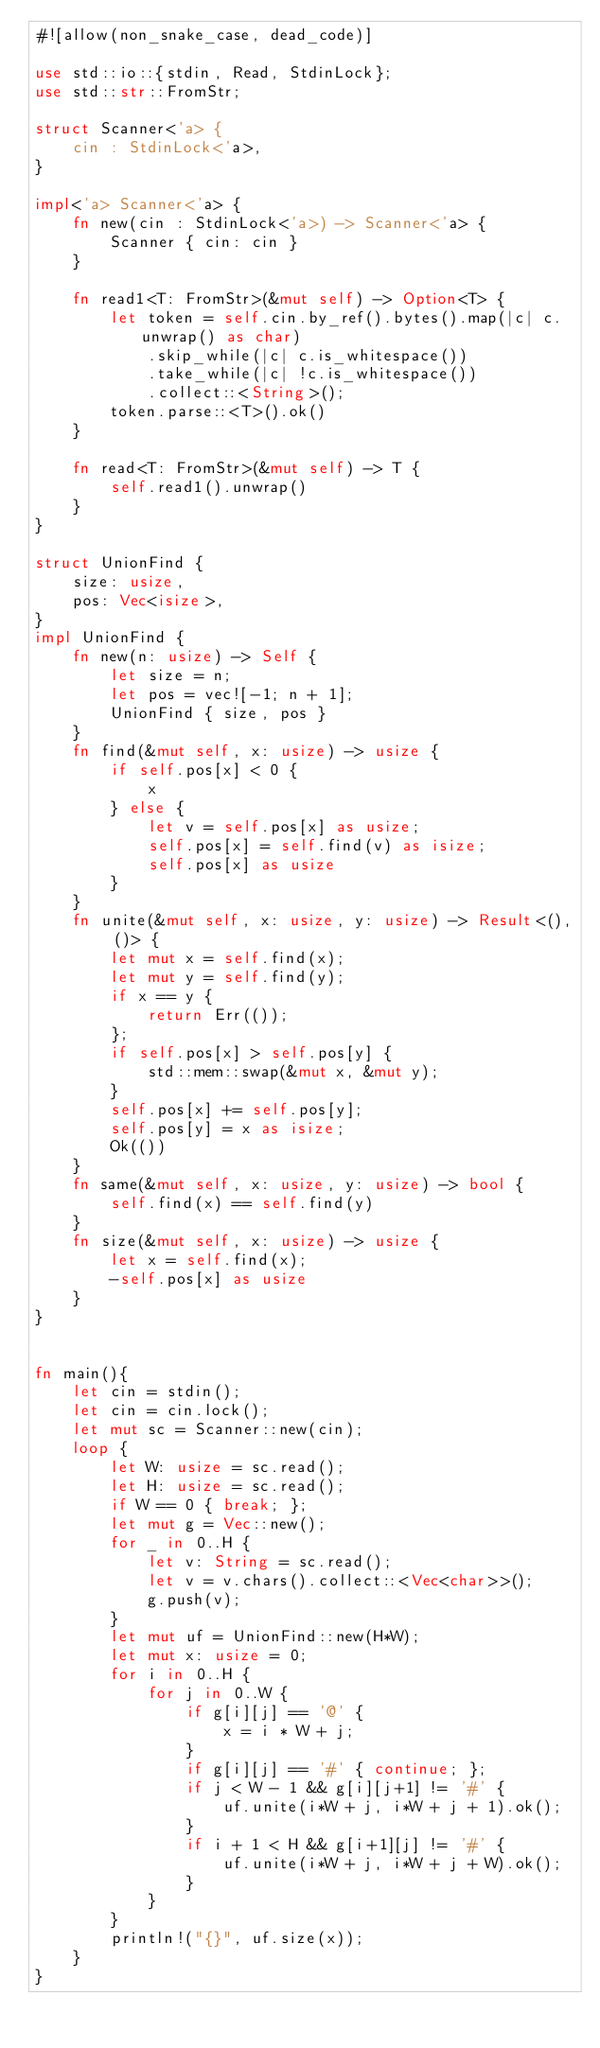<code> <loc_0><loc_0><loc_500><loc_500><_Rust_>#![allow(non_snake_case, dead_code)]

use std::io::{stdin, Read, StdinLock};
use std::str::FromStr;

struct Scanner<'a> {
    cin : StdinLock<'a>,
}

impl<'a> Scanner<'a> {
    fn new(cin : StdinLock<'a>) -> Scanner<'a> {
        Scanner { cin: cin }
    }

    fn read1<T: FromStr>(&mut self) -> Option<T> {
        let token = self.cin.by_ref().bytes().map(|c| c.unwrap() as char)
            .skip_while(|c| c.is_whitespace())
            .take_while(|c| !c.is_whitespace())
            .collect::<String>();
        token.parse::<T>().ok()
    }

    fn read<T: FromStr>(&mut self) -> T {
        self.read1().unwrap()
    }
}

struct UnionFind {
    size: usize,
    pos: Vec<isize>,
}
impl UnionFind {
    fn new(n: usize) -> Self {
        let size = n;
        let pos = vec![-1; n + 1];
        UnionFind { size, pos }
    }
    fn find(&mut self, x: usize) -> usize {
        if self.pos[x] < 0 {
            x
        } else {
            let v = self.pos[x] as usize;
            self.pos[x] = self.find(v) as isize;
            self.pos[x] as usize
        }
    }
    fn unite(&mut self, x: usize, y: usize) -> Result<(), ()> {
        let mut x = self.find(x);
        let mut y = self.find(y);
        if x == y {
            return Err(());
        };
        if self.pos[x] > self.pos[y] {
            std::mem::swap(&mut x, &mut y);
        }
        self.pos[x] += self.pos[y];
        self.pos[y] = x as isize;
        Ok(())
    }
    fn same(&mut self, x: usize, y: usize) -> bool {
        self.find(x) == self.find(y)
    }
    fn size(&mut self, x: usize) -> usize {
        let x = self.find(x);
        -self.pos[x] as usize
    }
}


fn main(){
    let cin = stdin();
    let cin = cin.lock();
    let mut sc = Scanner::new(cin);
    loop {
        let W: usize = sc.read();
        let H: usize = sc.read();
        if W == 0 { break; };
        let mut g = Vec::new();
        for _ in 0..H {
            let v: String = sc.read();
            let v = v.chars().collect::<Vec<char>>();
            g.push(v);
        }
        let mut uf = UnionFind::new(H*W);
        let mut x: usize = 0;
        for i in 0..H {
            for j in 0..W {
                if g[i][j] == '@' {
                    x = i * W + j;
                }
                if g[i][j] == '#' { continue; };
                if j < W - 1 && g[i][j+1] != '#' {
                    uf.unite(i*W + j, i*W + j + 1).ok();
                }
                if i + 1 < H && g[i+1][j] != '#' {
                    uf.unite(i*W + j, i*W + j + W).ok();
                }
            }
        }
        println!("{}", uf.size(x));
    }
}

</code> 